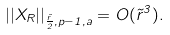Convert formula to latex. <formula><loc_0><loc_0><loc_500><loc_500>| | X _ { R } | | _ { \frac { \tilde { r } } { 2 } , p - 1 , a } = O ( \tilde { r } ^ { 3 } ) .</formula> 